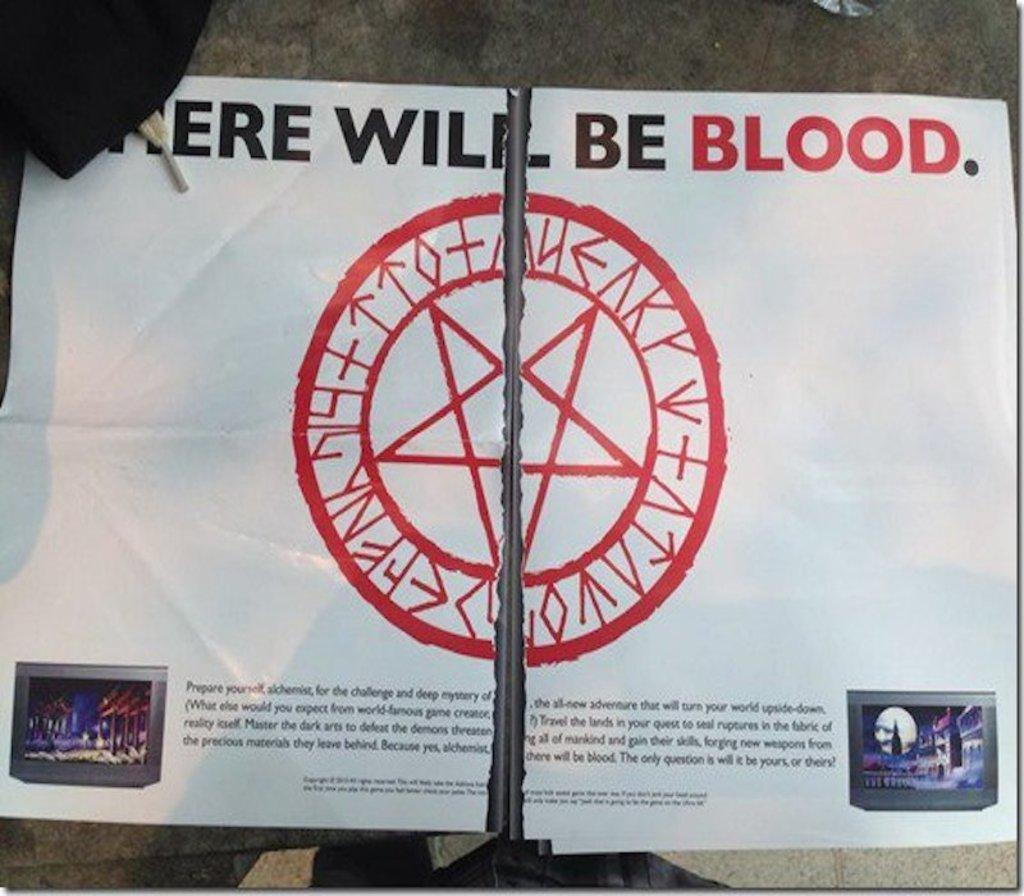What is located on the stone surface in the foreground of the image? There is a poster on the stone surface in the foreground of the image. Can you describe the object in the top left corner of the image? Unfortunately, the provided facts do not give any information about the object in the top left corner of the image. What type of war is depicted in the poster? There is no war depicted in the poster, as the provided facts do not mention any war-related content. Can you tell me how many frogs are present in the image? There are no frogs present in the image, as the provided facts do not mention any frogs. 